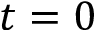<formula> <loc_0><loc_0><loc_500><loc_500>t = 0</formula> 